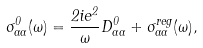<formula> <loc_0><loc_0><loc_500><loc_500>\sigma ^ { 0 } _ { \alpha \alpha } ( \omega ) = \frac { 2 i e ^ { 2 } } { \omega } D ^ { 0 } _ { \alpha \alpha } + \sigma _ { \alpha \alpha } ^ { r e g } ( \omega ) ,</formula> 